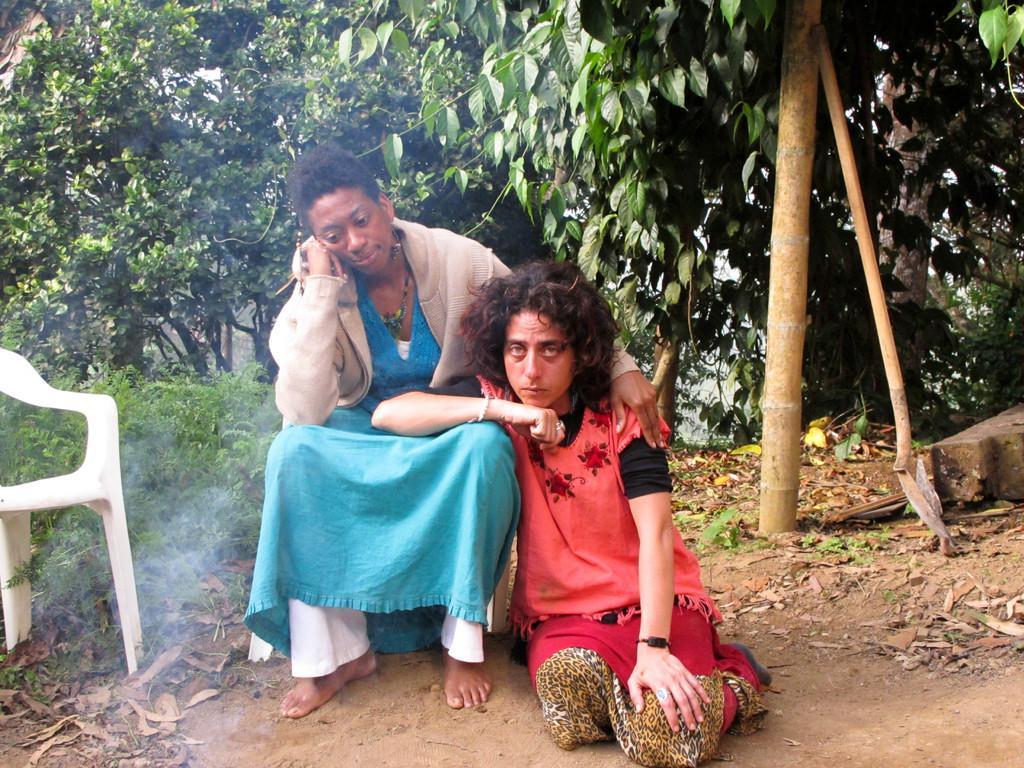Please provide a concise description of this image. In this image, there is an outside view. In the foreground, there are two persons wearing clothes. There is a chair on the left side of the image. In the background, there are some trees. 